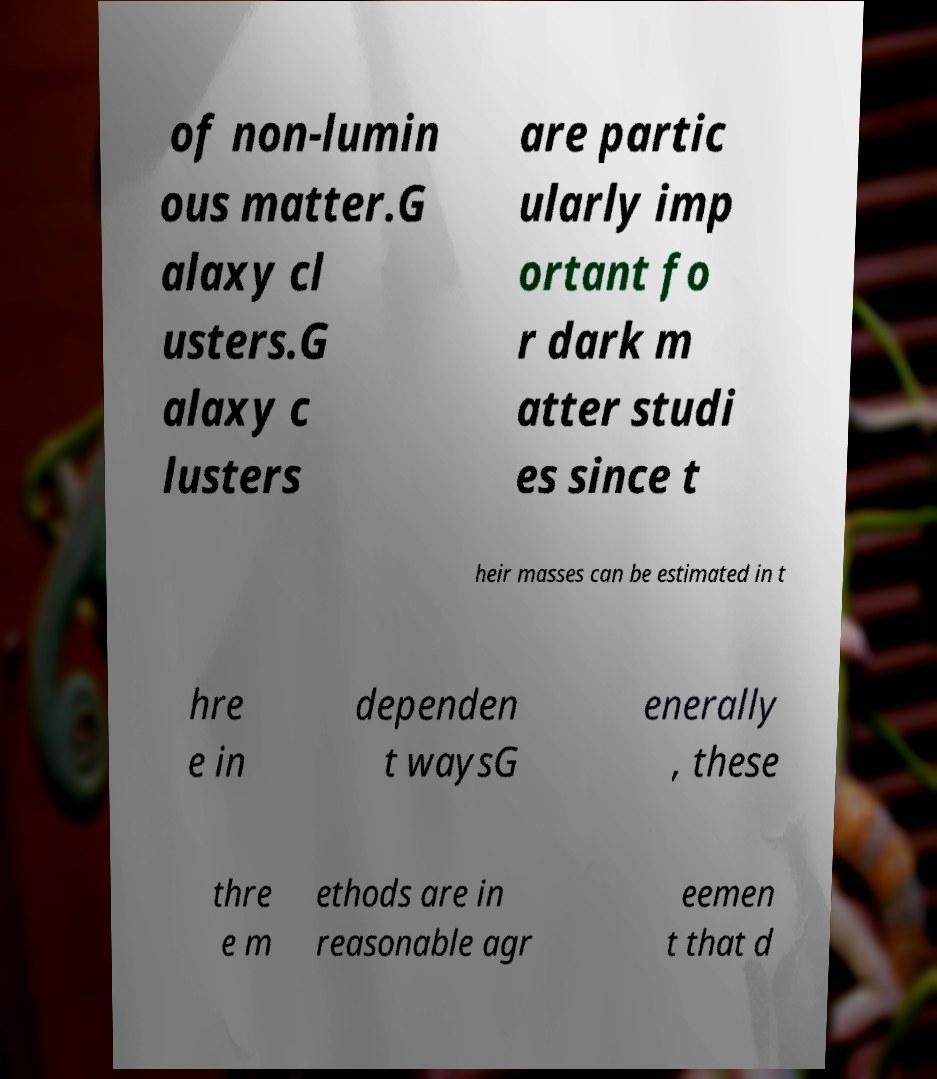For documentation purposes, I need the text within this image transcribed. Could you provide that? of non-lumin ous matter.G alaxy cl usters.G alaxy c lusters are partic ularly imp ortant fo r dark m atter studi es since t heir masses can be estimated in t hre e in dependen t waysG enerally , these thre e m ethods are in reasonable agr eemen t that d 